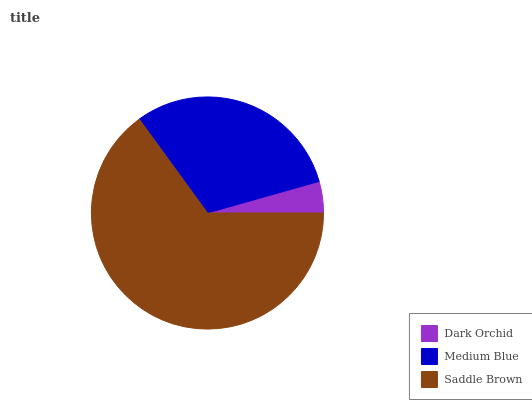Is Dark Orchid the minimum?
Answer yes or no. Yes. Is Saddle Brown the maximum?
Answer yes or no. Yes. Is Medium Blue the minimum?
Answer yes or no. No. Is Medium Blue the maximum?
Answer yes or no. No. Is Medium Blue greater than Dark Orchid?
Answer yes or no. Yes. Is Dark Orchid less than Medium Blue?
Answer yes or no. Yes. Is Dark Orchid greater than Medium Blue?
Answer yes or no. No. Is Medium Blue less than Dark Orchid?
Answer yes or no. No. Is Medium Blue the high median?
Answer yes or no. Yes. Is Medium Blue the low median?
Answer yes or no. Yes. Is Dark Orchid the high median?
Answer yes or no. No. Is Saddle Brown the low median?
Answer yes or no. No. 